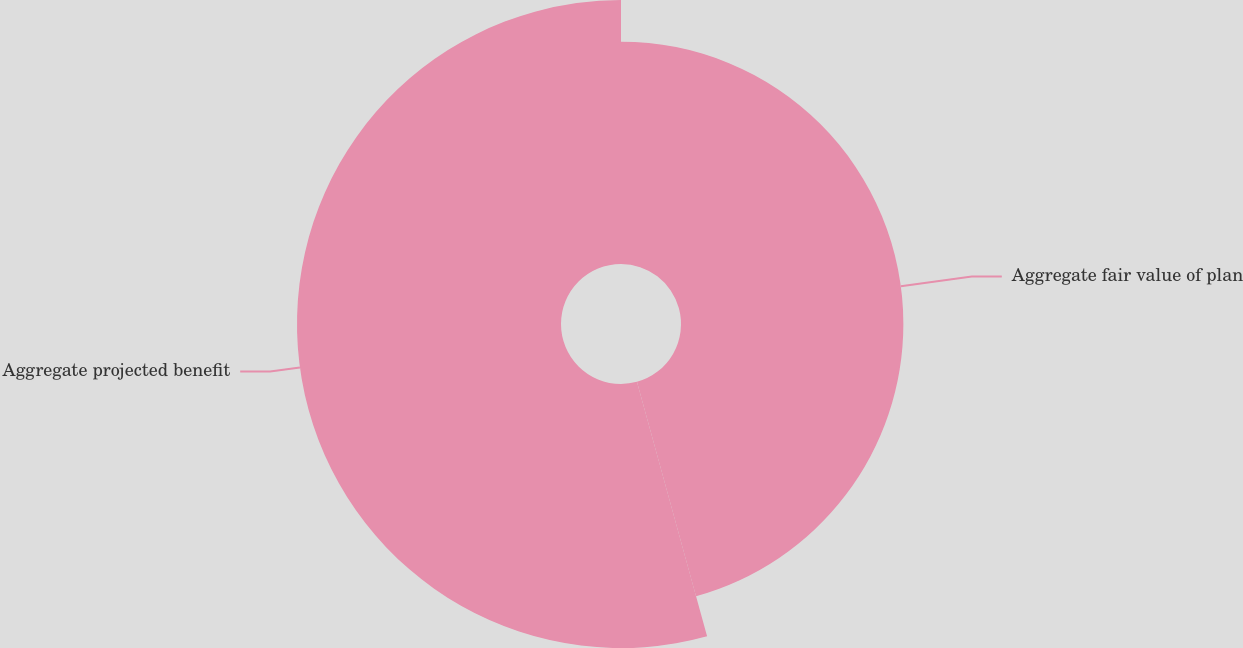<chart> <loc_0><loc_0><loc_500><loc_500><pie_chart><fcel>Aggregate fair value of plan<fcel>Aggregate projected benefit<nl><fcel>45.72%<fcel>54.28%<nl></chart> 